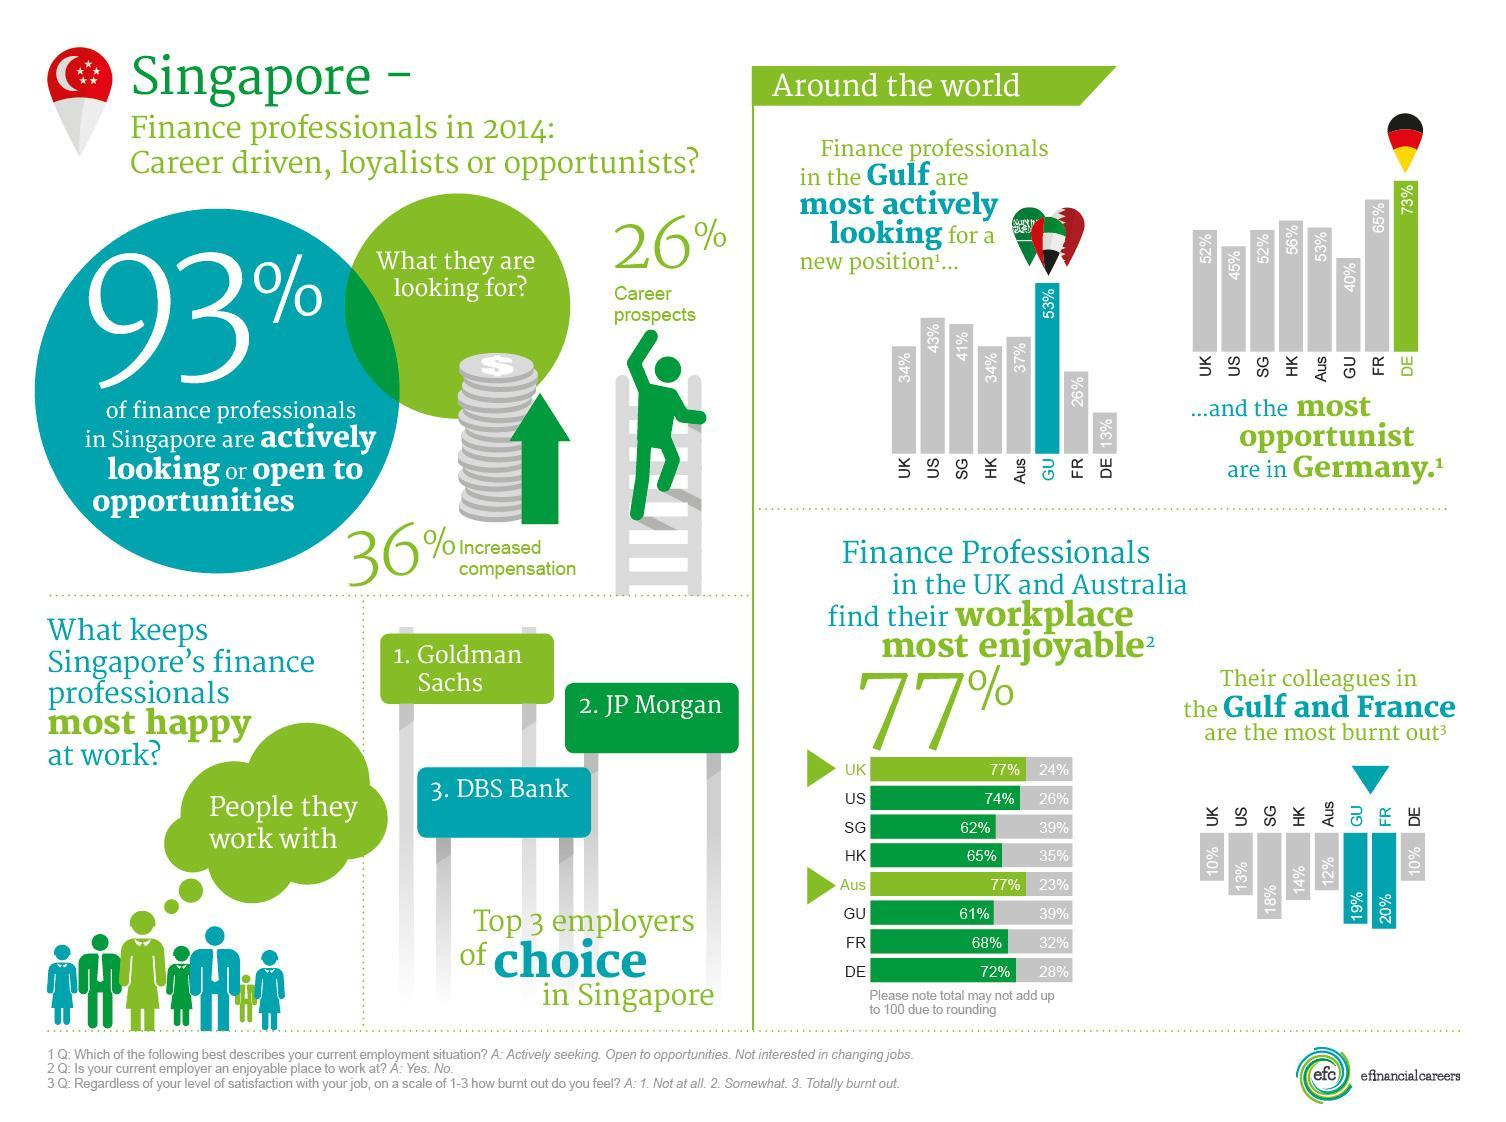Which employers are preferred by Singaporeans?
Answer the question with a short phrase. Goldman Sachs, JP Morgan, DBS Bank 